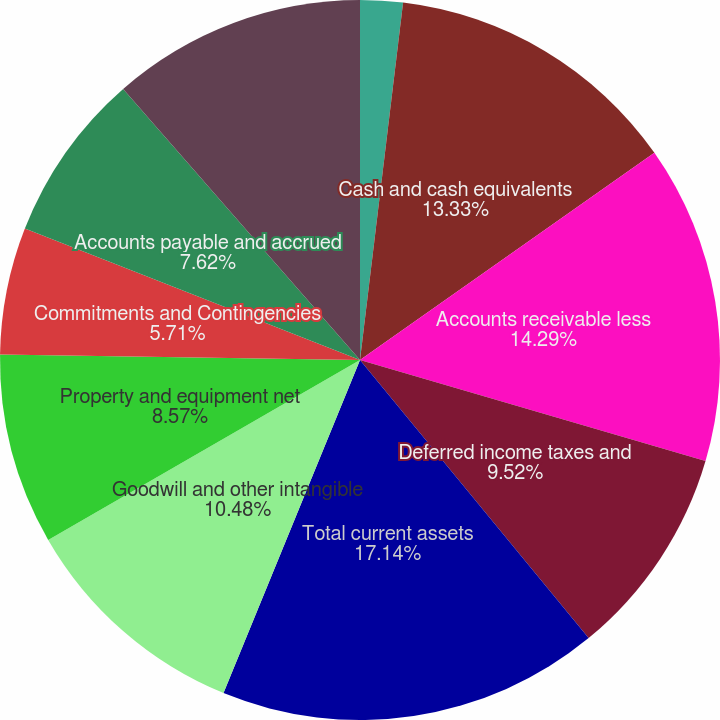Convert chart. <chart><loc_0><loc_0><loc_500><loc_500><pie_chart><fcel>DECEMBER 31 (in thousands<fcel>Cash and cash equivalents<fcel>Accounts receivable less<fcel>Deferred income taxes and<fcel>Total current assets<fcel>Goodwill and other intangible<fcel>Property and equipment net<fcel>Commitments and Contingencies<fcel>Accounts payable and accrued<fcel>Accrued payroll costs and<nl><fcel>1.91%<fcel>13.33%<fcel>14.29%<fcel>9.52%<fcel>17.14%<fcel>10.48%<fcel>8.57%<fcel>5.71%<fcel>7.62%<fcel>11.43%<nl></chart> 